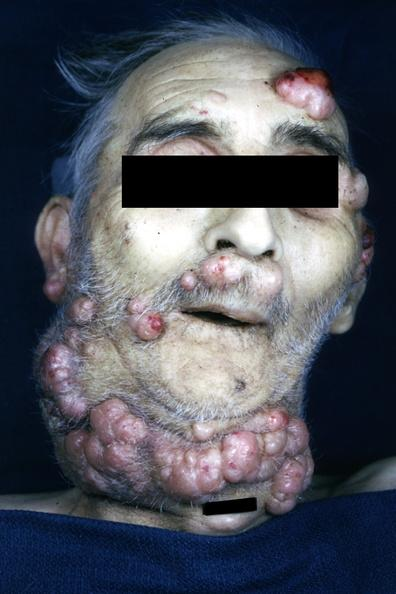what does this image show?
Answer the question using a single word or phrase. Photo of face and neck with multiple nodular lesions consisting of neoplastic plasma cells iga type 73yo man 